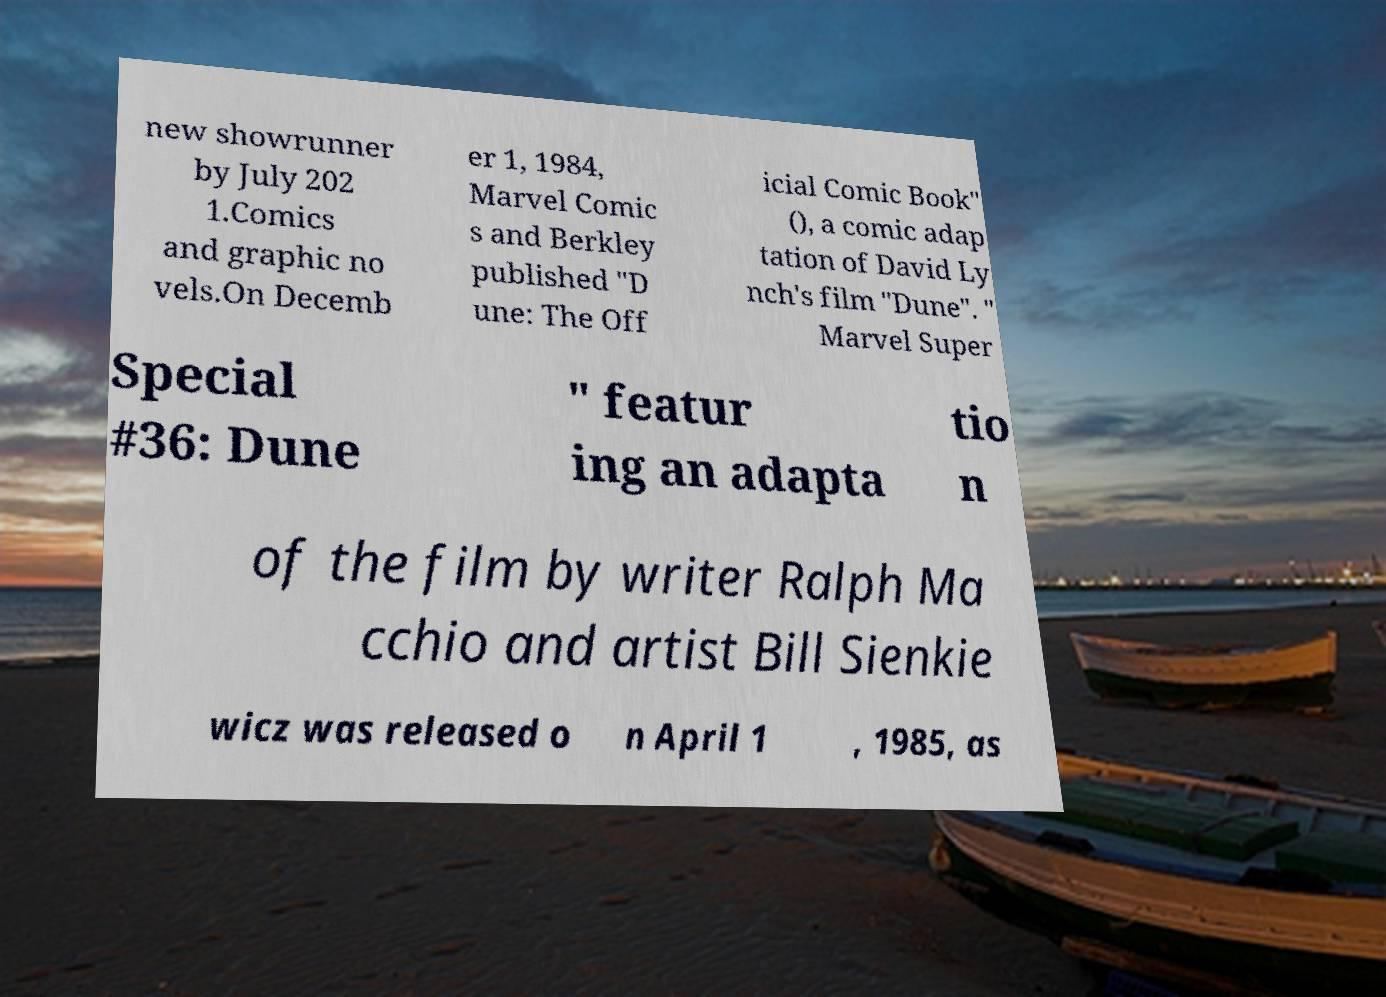Can you read and provide the text displayed in the image?This photo seems to have some interesting text. Can you extract and type it out for me? new showrunner by July 202 1.Comics and graphic no vels.On Decemb er 1, 1984, Marvel Comic s and Berkley published "D une: The Off icial Comic Book" (), a comic adap tation of David Ly nch's film "Dune". " Marvel Super Special #36: Dune " featur ing an adapta tio n of the film by writer Ralph Ma cchio and artist Bill Sienkie wicz was released o n April 1 , 1985, as 